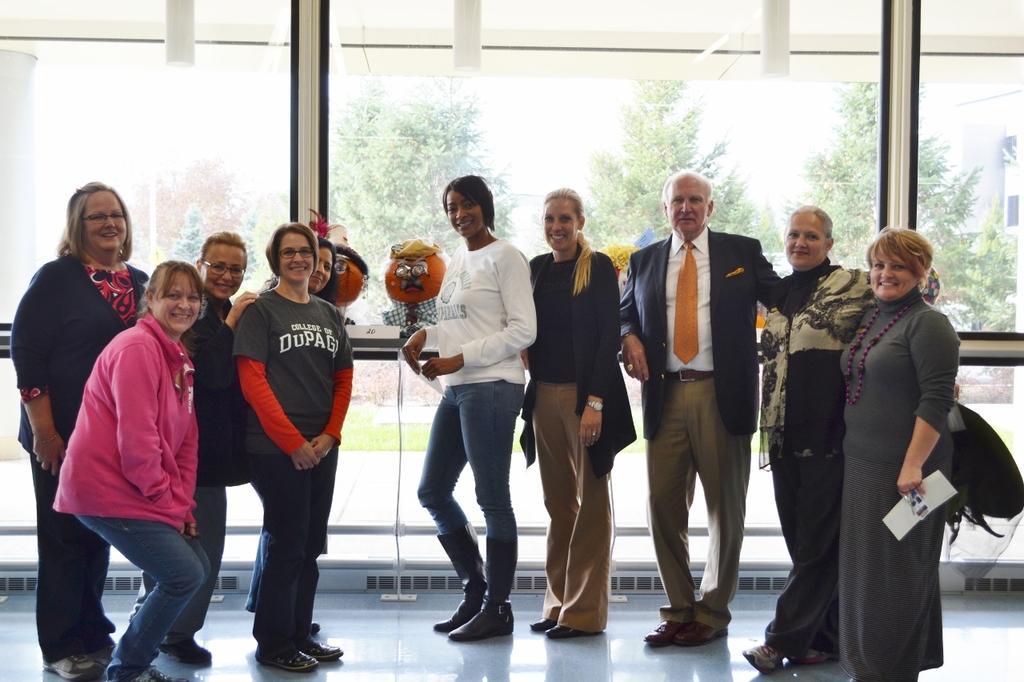Please provide a concise description of this image. In this image there are group of people standing and they are smiling, at the bottom there is floor. In the background there are some objects and glass door and through the door i can see some trees, buildings, grass and pavement. 